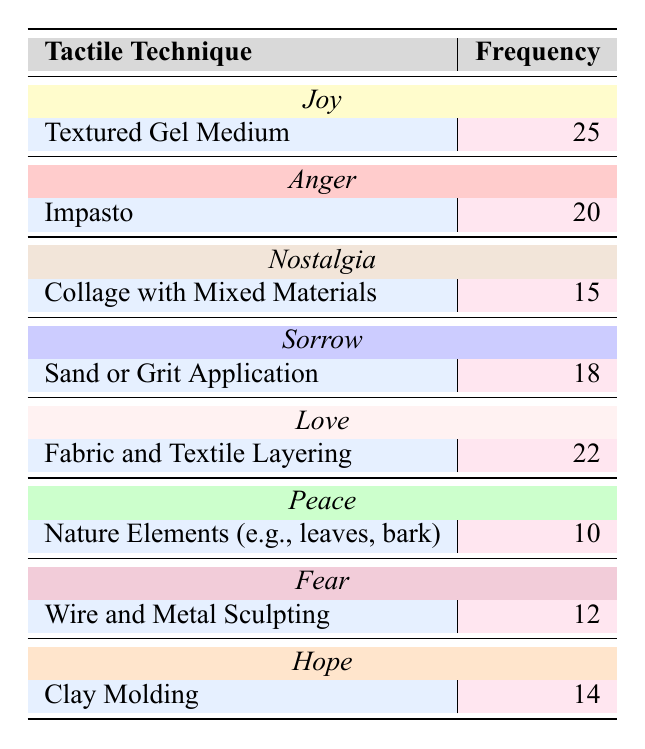What is the frequency of the "Textured Gel Medium" technique? The table states that the frequency of the "Textured Gel Medium" technique is directly mentioned right beside it, which is 25.
Answer: 25 Which sentiment is conveyed by the highest frequency tactile technique? The "Textured Gel Medium" technique conveys the sentiment of "Joy," and it has the highest frequency of 25.
Answer: Joy Is "Nature Elements (e.g., leaves, bark)" the least used technique? Upon examining the frequencies, "Nature Elements (e.g., leaves, bark)" has a frequency of 10, which is indeed the lowest compared to all other techniques listed.
Answer: Yes What is the sum of the frequencies for techniques conveying "Sorrow" and "Hope"? The frequency of "Sorrow" (which corresponds to "Sand or Grit Application") is 18, and for "Hope" (which corresponds to "Clay Molding") it is 14. Adding these together gives 18 + 14 = 32.
Answer: 32 How many total frequencies correspond to sentiments related to positive feelings (Joy, Love, Hope, Peace)? The frequencies for these sentiments are 25 (Joy), 22 (Love), 14 (Hope), and 10 (Peace). Summing these frequencies, we get 25 + 22 + 14 + 10 = 71.
Answer: 71 What technique expresses "Anger," and how frequently is it used? The technique that conveys "Anger" is "Impasto," which has a frequency of 20 listed right next to it.
Answer: Impasto, 20 Which two techniques have frequencies that add up to more than 30? Reviewing the table, "Textured Gel Medium" (25) and "Fabric and Textile Layering" (22) when added together produce 25 + 22 = 47, which is more than 30.
Answer: Textured Gel Medium and Fabric and Textile Layering Is there a tactile technique conveying "Fear" that has a lesser frequency than "Collage with Mixed Materials"? The technique for "Fear" is "Wire and Metal Sculpting," which has a frequency of 12. "Collage with Mixed Materials" has a frequency of 15. Thus, "Wire and Metal Sculpting" does have a lesser frequency than "Collage with Mixed Materials."
Answer: Yes 